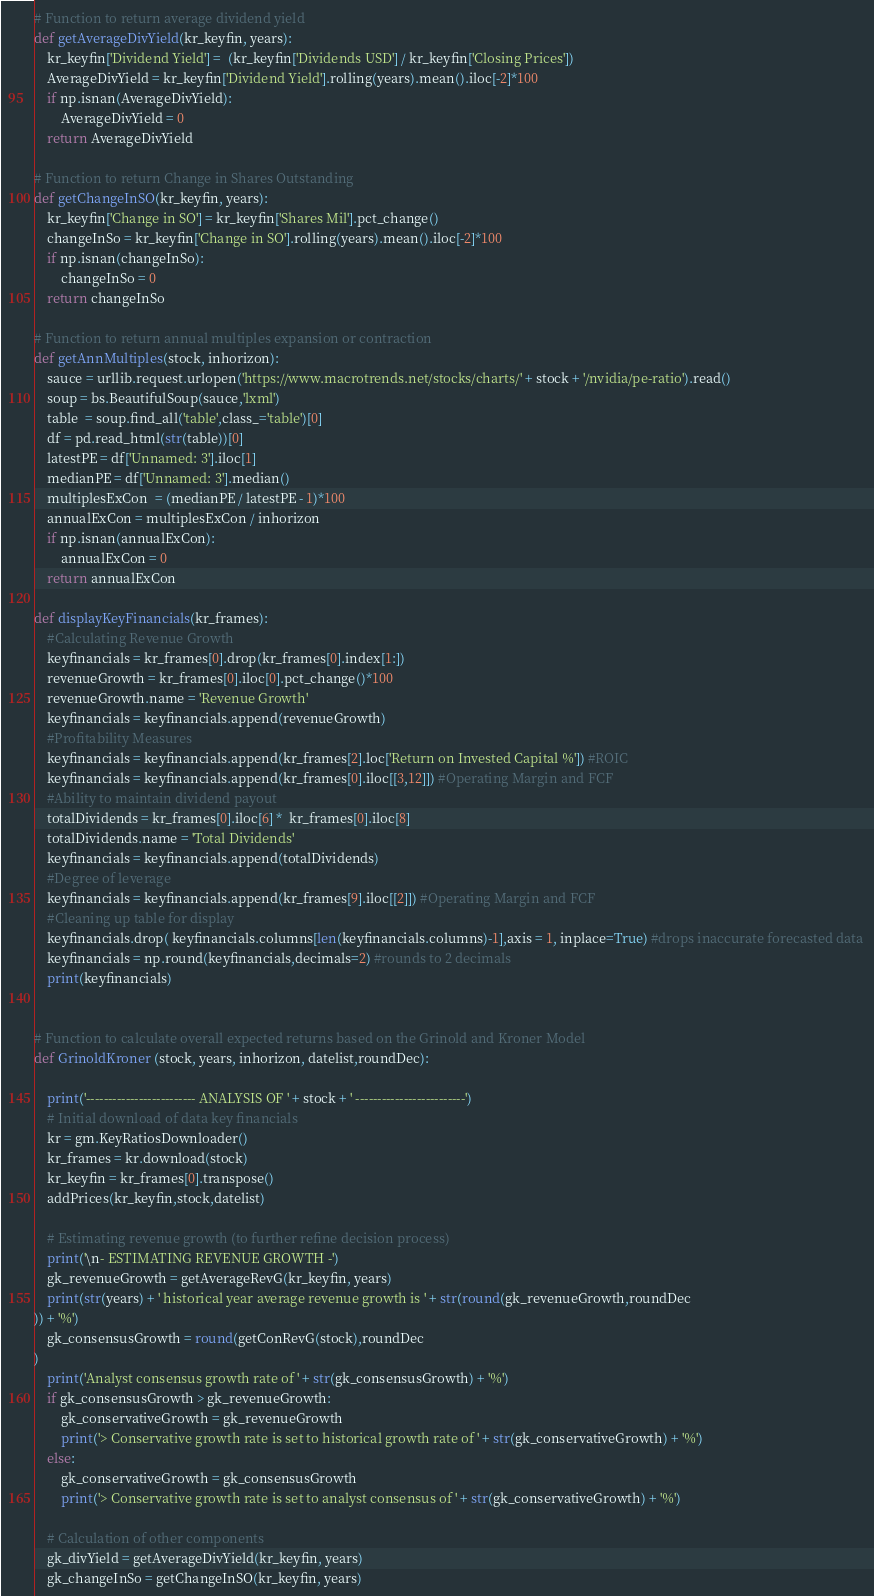Convert code to text. <code><loc_0><loc_0><loc_500><loc_500><_Python_>
# Function to return average dividend yield 
def getAverageDivYield(kr_keyfin, years):
    kr_keyfin['Dividend Yield'] =  (kr_keyfin['Dividends USD'] / kr_keyfin['Closing Prices'])
    AverageDivYield = kr_keyfin['Dividend Yield'].rolling(years).mean().iloc[-2]*100
    if np.isnan(AverageDivYield):
        AverageDivYield = 0
    return AverageDivYield

# Function to return Change in Shares Outstanding
def getChangeInSO(kr_keyfin, years):
    kr_keyfin['Change in SO'] = kr_keyfin['Shares Mil'].pct_change()
    changeInSo = kr_keyfin['Change in SO'].rolling(years).mean().iloc[-2]*100
    if np.isnan(changeInSo):
        changeInSo = 0
    return changeInSo

# Function to return annual multiples expansion or contraction
def getAnnMultiples(stock, inhorizon):
    sauce = urllib.request.urlopen('https://www.macrotrends.net/stocks/charts/' + stock + '/nvidia/pe-ratio').read()
    soup = bs.BeautifulSoup(sauce,'lxml')
    table  = soup.find_all('table',class_='table')[0]
    df = pd.read_html(str(table))[0]
    latestPE = df['Unnamed: 3'].iloc[1]
    medianPE = df['Unnamed: 3'].median()
    multiplesExCon  = (medianPE / latestPE - 1)*100
    annualExCon = multiplesExCon / inhorizon
    if np.isnan(annualExCon):
        annualExCon = 0
    return annualExCon

def displayKeyFinancials(kr_frames):
    #Calculating Revenue Growth
    keyfinancials = kr_frames[0].drop(kr_frames[0].index[1:])
    revenueGrowth = kr_frames[0].iloc[0].pct_change()*100
    revenueGrowth.name = 'Revenue Growth'
    keyfinancials = keyfinancials.append(revenueGrowth)
    #Profitability Measures
    keyfinancials = keyfinancials.append(kr_frames[2].loc['Return on Invested Capital %']) #ROIC
    keyfinancials = keyfinancials.append(kr_frames[0].iloc[[3,12]]) #Operating Margin and FCF
    #Ability to maintain dividend payout
    totalDividends = kr_frames[0].iloc[6] *  kr_frames[0].iloc[8]
    totalDividends.name = 'Total Dividends'
    keyfinancials = keyfinancials.append(totalDividends)
    #Degree of leverage
    keyfinancials = keyfinancials.append(kr_frames[9].iloc[[2]]) #Operating Margin and FCF
    #Cleaning up table for display
    keyfinancials.drop( keyfinancials.columns[len(keyfinancials.columns)-1],axis = 1, inplace=True) #drops inaccurate forecasted data 
    keyfinancials = np.round(keyfinancials,decimals=2) #rounds to 2 decimals
    print(keyfinancials)


# Function to calculate overall expected returns based on the Grinold and Kroner Model
def GrinoldKroner (stock, years, inhorizon, datelist,roundDec):
    
    print('------------------------- ANALYSIS OF ' + stock + ' -------------------------')
    # Initial download of data key financials
    kr = gm.KeyRatiosDownloader()
    kr_frames = kr.download(stock)
    kr_keyfin = kr_frames[0].transpose()
    addPrices(kr_keyfin,stock,datelist)

    # Estimating revenue growth (to further refine decision process)
    print('\n- ESTIMATING REVENUE GROWTH -')
    gk_revenueGrowth = getAverageRevG(kr_keyfin, years)
    print(str(years) + ' historical year average revenue growth is ' + str(round(gk_revenueGrowth,roundDec
)) + '%')
    gk_consensusGrowth = round(getConRevG(stock),roundDec
)
    print('Analyst consensus growth rate of ' + str(gk_consensusGrowth) + '%')
    if gk_consensusGrowth > gk_revenueGrowth:
        gk_conservativeGrowth = gk_revenueGrowth
        print('> Conservative growth rate is set to historical growth rate of ' + str(gk_conservativeGrowth) + '%')
    else:
        gk_conservativeGrowth = gk_consensusGrowth
        print('> Conservative growth rate is set to analyst consensus of ' + str(gk_conservativeGrowth) + '%')

    # Calculation of other components
    gk_divYield = getAverageDivYield(kr_keyfin, years)
    gk_changeInSo = getChangeInSO(kr_keyfin, years)</code> 